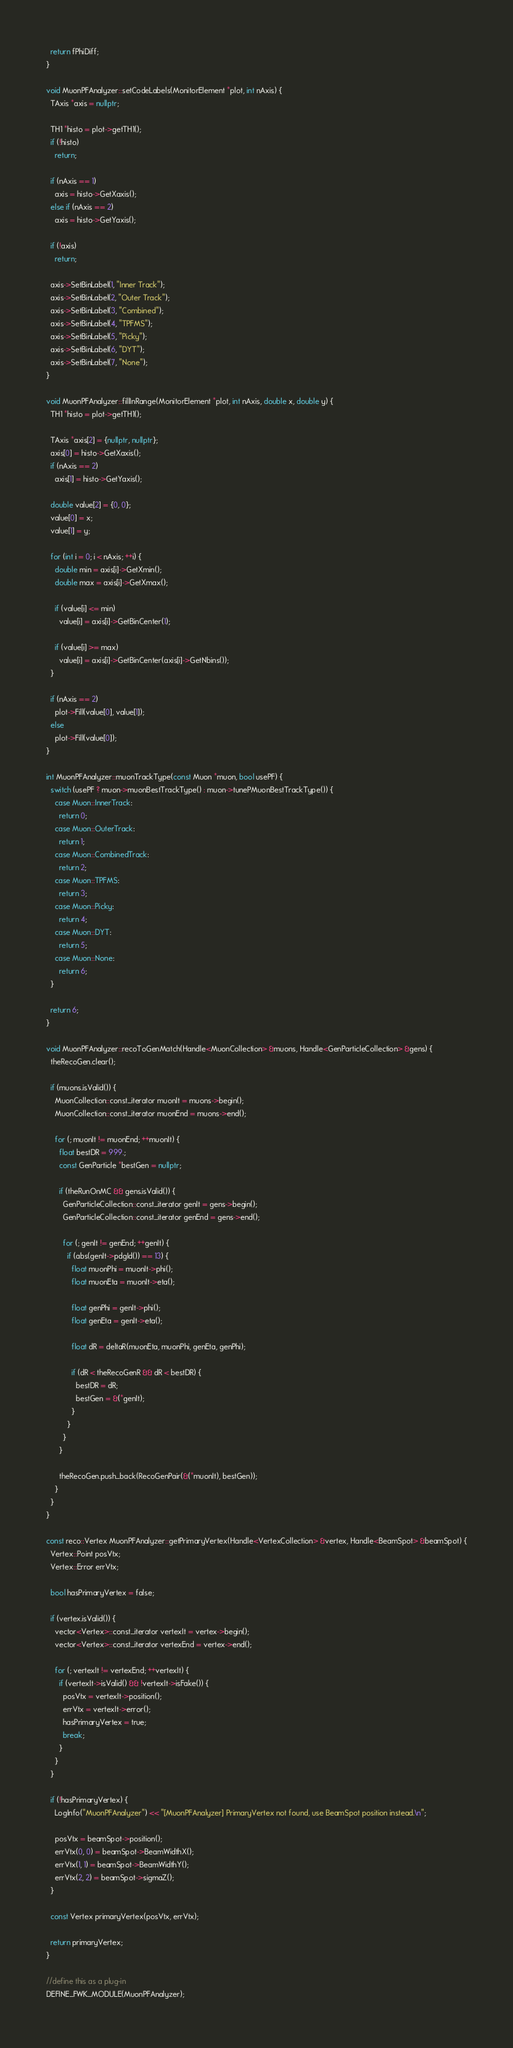Convert code to text. <code><loc_0><loc_0><loc_500><loc_500><_C++_>  return fPhiDiff;
}

void MuonPFAnalyzer::setCodeLabels(MonitorElement *plot, int nAxis) {
  TAxis *axis = nullptr;

  TH1 *histo = plot->getTH1();
  if (!histo)
    return;

  if (nAxis == 1)
    axis = histo->GetXaxis();
  else if (nAxis == 2)
    axis = histo->GetYaxis();

  if (!axis)
    return;

  axis->SetBinLabel(1, "Inner Track");
  axis->SetBinLabel(2, "Outer Track");
  axis->SetBinLabel(3, "Combined");
  axis->SetBinLabel(4, "TPFMS");
  axis->SetBinLabel(5, "Picky");
  axis->SetBinLabel(6, "DYT");
  axis->SetBinLabel(7, "None");
}

void MuonPFAnalyzer::fillInRange(MonitorElement *plot, int nAxis, double x, double y) {
  TH1 *histo = plot->getTH1();

  TAxis *axis[2] = {nullptr, nullptr};
  axis[0] = histo->GetXaxis();
  if (nAxis == 2)
    axis[1] = histo->GetYaxis();

  double value[2] = {0, 0};
  value[0] = x;
  value[1] = y;

  for (int i = 0; i < nAxis; ++i) {
    double min = axis[i]->GetXmin();
    double max = axis[i]->GetXmax();

    if (value[i] <= min)
      value[i] = axis[i]->GetBinCenter(1);

    if (value[i] >= max)
      value[i] = axis[i]->GetBinCenter(axis[i]->GetNbins());
  }

  if (nAxis == 2)
    plot->Fill(value[0], value[1]);
  else
    plot->Fill(value[0]);
}

int MuonPFAnalyzer::muonTrackType(const Muon *muon, bool usePF) {
  switch (usePF ? muon->muonBestTrackType() : muon->tunePMuonBestTrackType()) {
    case Muon::InnerTrack:
      return 0;
    case Muon::OuterTrack:
      return 1;
    case Muon::CombinedTrack:
      return 2;
    case Muon::TPFMS:
      return 3;
    case Muon::Picky:
      return 4;
    case Muon::DYT:
      return 5;
    case Muon::None:
      return 6;
  }

  return 6;
}

void MuonPFAnalyzer::recoToGenMatch(Handle<MuonCollection> &muons, Handle<GenParticleCollection> &gens) {
  theRecoGen.clear();

  if (muons.isValid()) {
    MuonCollection::const_iterator muonIt = muons->begin();
    MuonCollection::const_iterator muonEnd = muons->end();

    for (; muonIt != muonEnd; ++muonIt) {
      float bestDR = 999.;
      const GenParticle *bestGen = nullptr;

      if (theRunOnMC && gens.isValid()) {
        GenParticleCollection::const_iterator genIt = gens->begin();
        GenParticleCollection::const_iterator genEnd = gens->end();

        for (; genIt != genEnd; ++genIt) {
          if (abs(genIt->pdgId()) == 13) {
            float muonPhi = muonIt->phi();
            float muonEta = muonIt->eta();

            float genPhi = genIt->phi();
            float genEta = genIt->eta();

            float dR = deltaR(muonEta, muonPhi, genEta, genPhi);

            if (dR < theRecoGenR && dR < bestDR) {
              bestDR = dR;
              bestGen = &(*genIt);
            }
          }
        }
      }

      theRecoGen.push_back(RecoGenPair(&(*muonIt), bestGen));
    }
  }
}

const reco::Vertex MuonPFAnalyzer::getPrimaryVertex(Handle<VertexCollection> &vertex, Handle<BeamSpot> &beamSpot) {
  Vertex::Point posVtx;
  Vertex::Error errVtx;

  bool hasPrimaryVertex = false;

  if (vertex.isValid()) {
    vector<Vertex>::const_iterator vertexIt = vertex->begin();
    vector<Vertex>::const_iterator vertexEnd = vertex->end();

    for (; vertexIt != vertexEnd; ++vertexIt) {
      if (vertexIt->isValid() && !vertexIt->isFake()) {
        posVtx = vertexIt->position();
        errVtx = vertexIt->error();
        hasPrimaryVertex = true;
        break;
      }
    }
  }

  if (!hasPrimaryVertex) {
    LogInfo("MuonPFAnalyzer") << "[MuonPFAnalyzer] PrimaryVertex not found, use BeamSpot position instead.\n";

    posVtx = beamSpot->position();
    errVtx(0, 0) = beamSpot->BeamWidthX();
    errVtx(1, 1) = beamSpot->BeamWidthY();
    errVtx(2, 2) = beamSpot->sigmaZ();
  }

  const Vertex primaryVertex(posVtx, errVtx);

  return primaryVertex;
}

//define this as a plug-in
DEFINE_FWK_MODULE(MuonPFAnalyzer);
</code> 